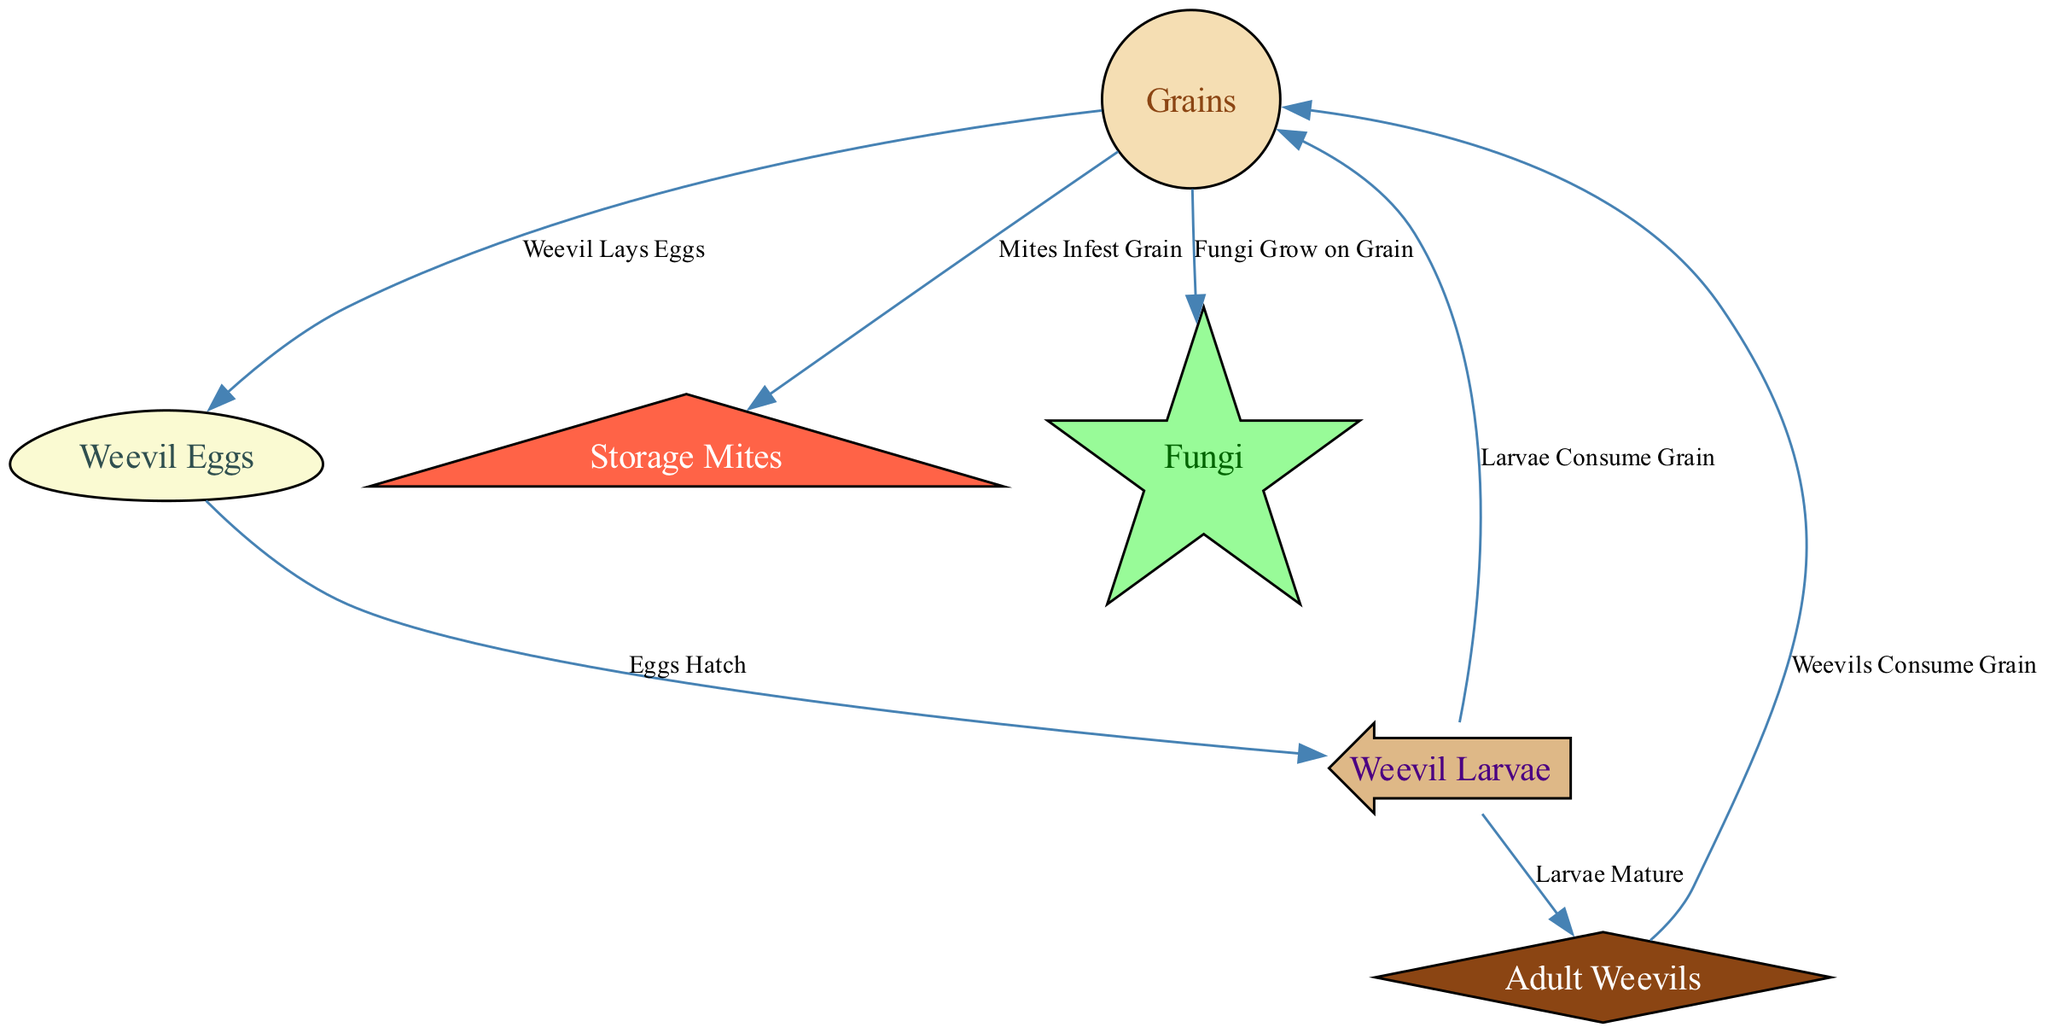What is the starting point of the food chain? The starting point of the food chain is identified by the node that does not have any incoming edges but has outgoing edges leading to other nodes. In this case, "Grains" is connected to several other nodes without being preyed upon itself.
Answer: Grains How many nodes are present in the diagram? To find the number of nodes, we count each unique element listed in the data under "nodes." There are a total of six distinct nodes including Grains, Weevil Eggs, Adult Weevils, Weevil Larvae, Storage Mites, and Fungi.
Answer: 6 What type of organism lays eggs? The diagram includes a relationship where "Weevil Eggs" are a product of eggs laid by an organism. Tracing backward from "Weevil Eggs," we identify "Adult Weevils" as the organisms responsible for laying these eggs.
Answer: Adult Weevils Which organism consumes grains other than larvae? Looking at the edges that lead from the "Grains" node, we see connections to both "Adult Weevils" and "Mites." These indicate that both Adult Weevils and Mites have a direct impact on the grains as they consume or infest them.
Answer: Adult Weevils What is consumed by weevil larvae? The edge labeled "Larvae Consume Grain" defines the relationship where weevil larvae have a direct predatory link to the grains. This means that weevil larvae specifically feed on grains as a vital part of their life cycle.
Answer: Grain How many edges are connecting all nodes in the diagram? To find this, we look at the "edges" section where the flow between nodes is detailed. By counting the connections listed, we observe that there are a total of seven edges showing interactions.
Answer: 7 What follows after weevil eggs hatch? The flow from "Weevil Eggs" leads to "Larvae" through the specific edge labeled "Eggs Hatch." This indicates that hatching of the eggs results directly in the emergence of larvae.
Answer: Larvae What type of organisms are involved in the spoiling of stored grains? In the edges that connect back to the "Grains" node, both "Mites" and "Fungi" have designated relationships that indicate they contribute to the spoilage or degradation of stored grains through infestation and growth respectively.
Answer: Mites, Fungi 